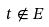<formula> <loc_0><loc_0><loc_500><loc_500>t \notin E</formula> 